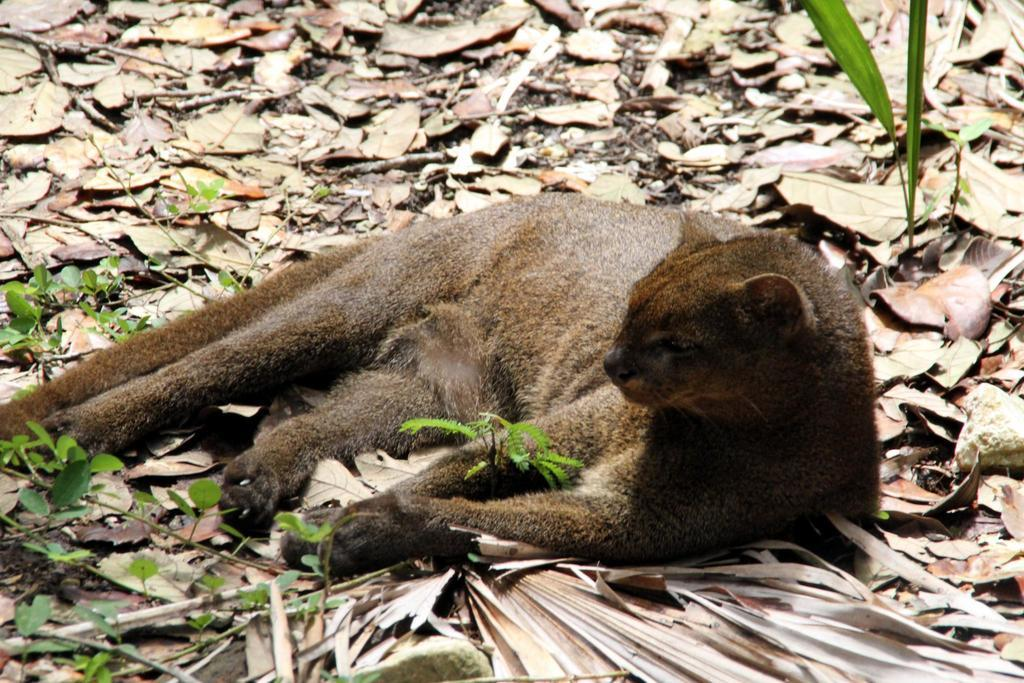What type of animal can be seen in the image? There is an animal lying on the surface in the image. What else is present in the image besides the animal? There are plants and dry leaves on the ground in the image. What type of print can be seen on the animal's mask in the image? There is no print or mask present on the animal in the image. 